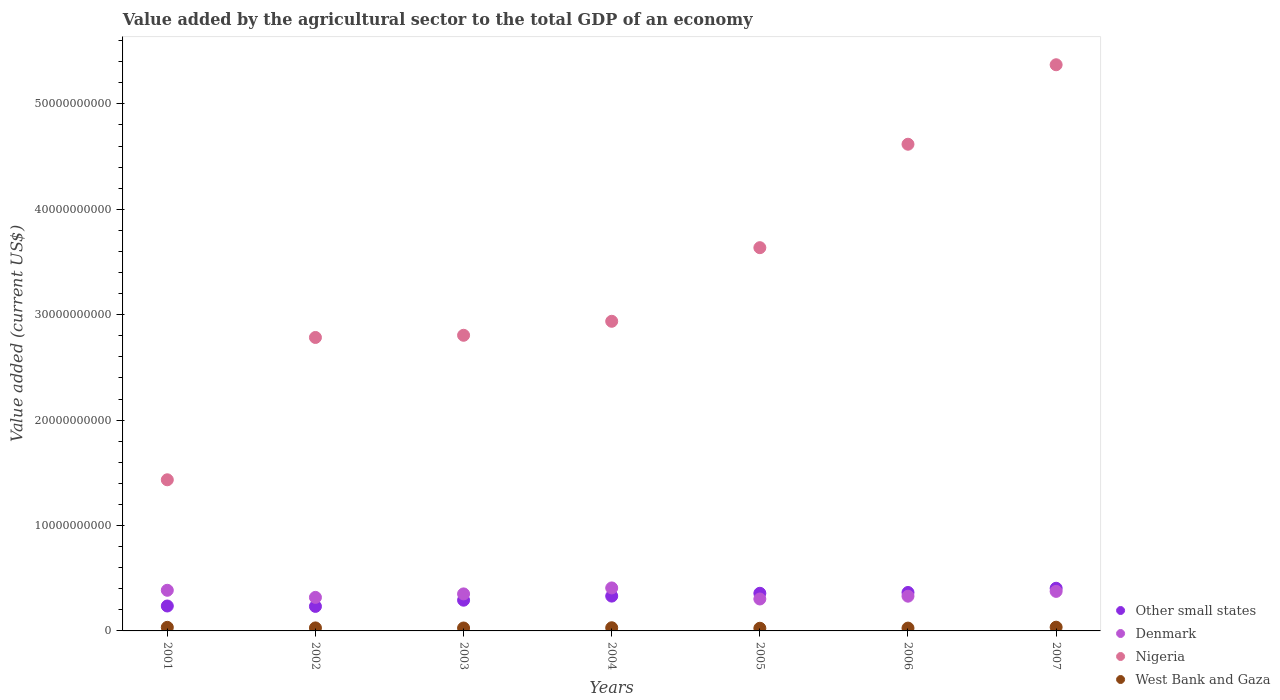How many different coloured dotlines are there?
Provide a short and direct response. 4. What is the value added by the agricultural sector to the total GDP in Nigeria in 2001?
Offer a terse response. 1.43e+1. Across all years, what is the maximum value added by the agricultural sector to the total GDP in West Bank and Gaza?
Give a very brief answer. 3.54e+08. Across all years, what is the minimum value added by the agricultural sector to the total GDP in Other small states?
Ensure brevity in your answer.  2.33e+09. What is the total value added by the agricultural sector to the total GDP in Other small states in the graph?
Keep it short and to the point. 2.22e+1. What is the difference between the value added by the agricultural sector to the total GDP in Nigeria in 2002 and that in 2004?
Provide a succinct answer. -1.53e+09. What is the difference between the value added by the agricultural sector to the total GDP in West Bank and Gaza in 2002 and the value added by the agricultural sector to the total GDP in Denmark in 2001?
Give a very brief answer. -3.57e+09. What is the average value added by the agricultural sector to the total GDP in West Bank and Gaza per year?
Your response must be concise. 2.97e+08. In the year 2002, what is the difference between the value added by the agricultural sector to the total GDP in Denmark and value added by the agricultural sector to the total GDP in Nigeria?
Give a very brief answer. -2.47e+1. What is the ratio of the value added by the agricultural sector to the total GDP in West Bank and Gaza in 2002 to that in 2006?
Offer a very short reply. 1.07. Is the value added by the agricultural sector to the total GDP in Denmark in 2001 less than that in 2002?
Offer a terse response. No. Is the difference between the value added by the agricultural sector to the total GDP in Denmark in 2001 and 2005 greater than the difference between the value added by the agricultural sector to the total GDP in Nigeria in 2001 and 2005?
Keep it short and to the point. Yes. What is the difference between the highest and the second highest value added by the agricultural sector to the total GDP in West Bank and Gaza?
Ensure brevity in your answer.  1.41e+07. What is the difference between the highest and the lowest value added by the agricultural sector to the total GDP in West Bank and Gaza?
Ensure brevity in your answer.  1.00e+08. Is the sum of the value added by the agricultural sector to the total GDP in Denmark in 2004 and 2006 greater than the maximum value added by the agricultural sector to the total GDP in Nigeria across all years?
Make the answer very short. No. Is it the case that in every year, the sum of the value added by the agricultural sector to the total GDP in Denmark and value added by the agricultural sector to the total GDP in Other small states  is greater than the value added by the agricultural sector to the total GDP in Nigeria?
Give a very brief answer. No. Is the value added by the agricultural sector to the total GDP in West Bank and Gaza strictly greater than the value added by the agricultural sector to the total GDP in Denmark over the years?
Make the answer very short. No. How many dotlines are there?
Keep it short and to the point. 4. Does the graph contain any zero values?
Provide a short and direct response. No. Where does the legend appear in the graph?
Provide a succinct answer. Bottom right. How many legend labels are there?
Your answer should be compact. 4. How are the legend labels stacked?
Give a very brief answer. Vertical. What is the title of the graph?
Your answer should be very brief. Value added by the agricultural sector to the total GDP of an economy. Does "El Salvador" appear as one of the legend labels in the graph?
Your answer should be very brief. No. What is the label or title of the X-axis?
Provide a short and direct response. Years. What is the label or title of the Y-axis?
Provide a short and direct response. Value added (current US$). What is the Value added (current US$) of Other small states in 2001?
Keep it short and to the point. 2.36e+09. What is the Value added (current US$) in Denmark in 2001?
Provide a succinct answer. 3.86e+09. What is the Value added (current US$) of Nigeria in 2001?
Offer a terse response. 1.43e+1. What is the Value added (current US$) in West Bank and Gaza in 2001?
Your answer should be compact. 3.40e+08. What is the Value added (current US$) in Other small states in 2002?
Your answer should be compact. 2.33e+09. What is the Value added (current US$) of Denmark in 2002?
Keep it short and to the point. 3.18e+09. What is the Value added (current US$) in Nigeria in 2002?
Provide a short and direct response. 2.78e+1. What is the Value added (current US$) in West Bank and Gaza in 2002?
Make the answer very short. 2.86e+08. What is the Value added (current US$) of Other small states in 2003?
Offer a terse response. 2.92e+09. What is the Value added (current US$) in Denmark in 2003?
Your response must be concise. 3.51e+09. What is the Value added (current US$) in Nigeria in 2003?
Offer a very short reply. 2.80e+1. What is the Value added (current US$) in West Bank and Gaza in 2003?
Provide a succinct answer. 2.76e+08. What is the Value added (current US$) in Other small states in 2004?
Provide a short and direct response. 3.30e+09. What is the Value added (current US$) of Denmark in 2004?
Provide a succinct answer. 4.08e+09. What is the Value added (current US$) in Nigeria in 2004?
Your response must be concise. 2.94e+1. What is the Value added (current US$) of West Bank and Gaza in 2004?
Offer a very short reply. 3.00e+08. What is the Value added (current US$) in Other small states in 2005?
Provide a succinct answer. 3.57e+09. What is the Value added (current US$) of Denmark in 2005?
Your response must be concise. 3.03e+09. What is the Value added (current US$) of Nigeria in 2005?
Keep it short and to the point. 3.64e+1. What is the Value added (current US$) in West Bank and Gaza in 2005?
Make the answer very short. 2.53e+08. What is the Value added (current US$) of Other small states in 2006?
Your answer should be compact. 3.65e+09. What is the Value added (current US$) of Denmark in 2006?
Your answer should be very brief. 3.30e+09. What is the Value added (current US$) in Nigeria in 2006?
Offer a very short reply. 4.62e+1. What is the Value added (current US$) of West Bank and Gaza in 2006?
Keep it short and to the point. 2.68e+08. What is the Value added (current US$) in Other small states in 2007?
Offer a very short reply. 4.05e+09. What is the Value added (current US$) in Denmark in 2007?
Make the answer very short. 3.75e+09. What is the Value added (current US$) in Nigeria in 2007?
Provide a succinct answer. 5.37e+1. What is the Value added (current US$) in West Bank and Gaza in 2007?
Make the answer very short. 3.54e+08. Across all years, what is the maximum Value added (current US$) of Other small states?
Ensure brevity in your answer.  4.05e+09. Across all years, what is the maximum Value added (current US$) in Denmark?
Your answer should be very brief. 4.08e+09. Across all years, what is the maximum Value added (current US$) of Nigeria?
Your response must be concise. 5.37e+1. Across all years, what is the maximum Value added (current US$) of West Bank and Gaza?
Your response must be concise. 3.54e+08. Across all years, what is the minimum Value added (current US$) of Other small states?
Provide a short and direct response. 2.33e+09. Across all years, what is the minimum Value added (current US$) of Denmark?
Provide a succinct answer. 3.03e+09. Across all years, what is the minimum Value added (current US$) in Nigeria?
Provide a short and direct response. 1.43e+1. Across all years, what is the minimum Value added (current US$) of West Bank and Gaza?
Give a very brief answer. 2.53e+08. What is the total Value added (current US$) in Other small states in the graph?
Offer a terse response. 2.22e+1. What is the total Value added (current US$) in Denmark in the graph?
Keep it short and to the point. 2.47e+1. What is the total Value added (current US$) of Nigeria in the graph?
Offer a terse response. 2.36e+11. What is the total Value added (current US$) in West Bank and Gaza in the graph?
Offer a terse response. 2.08e+09. What is the difference between the Value added (current US$) in Other small states in 2001 and that in 2002?
Your answer should be very brief. 3.70e+07. What is the difference between the Value added (current US$) of Denmark in 2001 and that in 2002?
Keep it short and to the point. 6.74e+08. What is the difference between the Value added (current US$) in Nigeria in 2001 and that in 2002?
Make the answer very short. -1.35e+1. What is the difference between the Value added (current US$) in West Bank and Gaza in 2001 and that in 2002?
Your answer should be compact. 5.38e+07. What is the difference between the Value added (current US$) of Other small states in 2001 and that in 2003?
Make the answer very short. -5.50e+08. What is the difference between the Value added (current US$) in Denmark in 2001 and that in 2003?
Offer a very short reply. 3.42e+08. What is the difference between the Value added (current US$) in Nigeria in 2001 and that in 2003?
Your answer should be very brief. -1.37e+1. What is the difference between the Value added (current US$) of West Bank and Gaza in 2001 and that in 2003?
Ensure brevity in your answer.  6.32e+07. What is the difference between the Value added (current US$) in Other small states in 2001 and that in 2004?
Provide a short and direct response. -9.38e+08. What is the difference between the Value added (current US$) in Denmark in 2001 and that in 2004?
Your answer should be very brief. -2.23e+08. What is the difference between the Value added (current US$) in Nigeria in 2001 and that in 2004?
Provide a succinct answer. -1.50e+1. What is the difference between the Value added (current US$) of West Bank and Gaza in 2001 and that in 2004?
Keep it short and to the point. 3.97e+07. What is the difference between the Value added (current US$) in Other small states in 2001 and that in 2005?
Offer a very short reply. -1.21e+09. What is the difference between the Value added (current US$) of Denmark in 2001 and that in 2005?
Make the answer very short. 8.25e+08. What is the difference between the Value added (current US$) of Nigeria in 2001 and that in 2005?
Provide a short and direct response. -2.20e+1. What is the difference between the Value added (current US$) of West Bank and Gaza in 2001 and that in 2005?
Your response must be concise. 8.61e+07. What is the difference between the Value added (current US$) in Other small states in 2001 and that in 2006?
Ensure brevity in your answer.  -1.28e+09. What is the difference between the Value added (current US$) in Denmark in 2001 and that in 2006?
Provide a short and direct response. 5.59e+08. What is the difference between the Value added (current US$) of Nigeria in 2001 and that in 2006?
Your answer should be compact. -3.18e+1. What is the difference between the Value added (current US$) in West Bank and Gaza in 2001 and that in 2006?
Your response must be concise. 7.17e+07. What is the difference between the Value added (current US$) in Other small states in 2001 and that in 2007?
Your response must be concise. -1.68e+09. What is the difference between the Value added (current US$) of Denmark in 2001 and that in 2007?
Make the answer very short. 1.04e+08. What is the difference between the Value added (current US$) in Nigeria in 2001 and that in 2007?
Your answer should be compact. -3.94e+1. What is the difference between the Value added (current US$) of West Bank and Gaza in 2001 and that in 2007?
Ensure brevity in your answer.  -1.41e+07. What is the difference between the Value added (current US$) in Other small states in 2002 and that in 2003?
Offer a very short reply. -5.87e+08. What is the difference between the Value added (current US$) in Denmark in 2002 and that in 2003?
Ensure brevity in your answer.  -3.31e+08. What is the difference between the Value added (current US$) of Nigeria in 2002 and that in 2003?
Your answer should be very brief. -2.08e+08. What is the difference between the Value added (current US$) in West Bank and Gaza in 2002 and that in 2003?
Ensure brevity in your answer.  9.34e+06. What is the difference between the Value added (current US$) of Other small states in 2002 and that in 2004?
Ensure brevity in your answer.  -9.75e+08. What is the difference between the Value added (current US$) in Denmark in 2002 and that in 2004?
Ensure brevity in your answer.  -8.97e+08. What is the difference between the Value added (current US$) of Nigeria in 2002 and that in 2004?
Provide a short and direct response. -1.53e+09. What is the difference between the Value added (current US$) in West Bank and Gaza in 2002 and that in 2004?
Your answer should be compact. -1.41e+07. What is the difference between the Value added (current US$) of Other small states in 2002 and that in 2005?
Offer a terse response. -1.24e+09. What is the difference between the Value added (current US$) of Denmark in 2002 and that in 2005?
Make the answer very short. 1.52e+08. What is the difference between the Value added (current US$) of Nigeria in 2002 and that in 2005?
Your answer should be compact. -8.52e+09. What is the difference between the Value added (current US$) of West Bank and Gaza in 2002 and that in 2005?
Your response must be concise. 3.23e+07. What is the difference between the Value added (current US$) in Other small states in 2002 and that in 2006?
Keep it short and to the point. -1.32e+09. What is the difference between the Value added (current US$) in Denmark in 2002 and that in 2006?
Keep it short and to the point. -1.14e+08. What is the difference between the Value added (current US$) in Nigeria in 2002 and that in 2006?
Ensure brevity in your answer.  -1.83e+1. What is the difference between the Value added (current US$) of West Bank and Gaza in 2002 and that in 2006?
Provide a succinct answer. 1.79e+07. What is the difference between the Value added (current US$) of Other small states in 2002 and that in 2007?
Offer a very short reply. -1.72e+09. What is the difference between the Value added (current US$) of Denmark in 2002 and that in 2007?
Provide a short and direct response. -5.70e+08. What is the difference between the Value added (current US$) in Nigeria in 2002 and that in 2007?
Make the answer very short. -2.59e+1. What is the difference between the Value added (current US$) in West Bank and Gaza in 2002 and that in 2007?
Provide a succinct answer. -6.79e+07. What is the difference between the Value added (current US$) of Other small states in 2003 and that in 2004?
Provide a succinct answer. -3.88e+08. What is the difference between the Value added (current US$) in Denmark in 2003 and that in 2004?
Offer a very short reply. -5.65e+08. What is the difference between the Value added (current US$) of Nigeria in 2003 and that in 2004?
Provide a succinct answer. -1.33e+09. What is the difference between the Value added (current US$) of West Bank and Gaza in 2003 and that in 2004?
Keep it short and to the point. -2.35e+07. What is the difference between the Value added (current US$) in Other small states in 2003 and that in 2005?
Your answer should be compact. -6.55e+08. What is the difference between the Value added (current US$) in Denmark in 2003 and that in 2005?
Provide a short and direct response. 4.83e+08. What is the difference between the Value added (current US$) of Nigeria in 2003 and that in 2005?
Give a very brief answer. -8.31e+09. What is the difference between the Value added (current US$) of West Bank and Gaza in 2003 and that in 2005?
Offer a very short reply. 2.30e+07. What is the difference between the Value added (current US$) of Other small states in 2003 and that in 2006?
Offer a terse response. -7.32e+08. What is the difference between the Value added (current US$) in Denmark in 2003 and that in 2006?
Your answer should be very brief. 2.17e+08. What is the difference between the Value added (current US$) in Nigeria in 2003 and that in 2006?
Make the answer very short. -1.81e+1. What is the difference between the Value added (current US$) of West Bank and Gaza in 2003 and that in 2006?
Make the answer very short. 8.54e+06. What is the difference between the Value added (current US$) in Other small states in 2003 and that in 2007?
Offer a very short reply. -1.13e+09. What is the difference between the Value added (current US$) in Denmark in 2003 and that in 2007?
Your answer should be compact. -2.38e+08. What is the difference between the Value added (current US$) of Nigeria in 2003 and that in 2007?
Make the answer very short. -2.57e+1. What is the difference between the Value added (current US$) of West Bank and Gaza in 2003 and that in 2007?
Give a very brief answer. -7.73e+07. What is the difference between the Value added (current US$) of Other small states in 2004 and that in 2005?
Make the answer very short. -2.68e+08. What is the difference between the Value added (current US$) of Denmark in 2004 and that in 2005?
Provide a short and direct response. 1.05e+09. What is the difference between the Value added (current US$) in Nigeria in 2004 and that in 2005?
Your answer should be very brief. -6.98e+09. What is the difference between the Value added (current US$) in West Bank and Gaza in 2004 and that in 2005?
Offer a terse response. 4.64e+07. What is the difference between the Value added (current US$) of Other small states in 2004 and that in 2006?
Offer a very short reply. -3.44e+08. What is the difference between the Value added (current US$) in Denmark in 2004 and that in 2006?
Your answer should be very brief. 7.82e+08. What is the difference between the Value added (current US$) in Nigeria in 2004 and that in 2006?
Your response must be concise. -1.68e+1. What is the difference between the Value added (current US$) in West Bank and Gaza in 2004 and that in 2006?
Provide a short and direct response. 3.20e+07. What is the difference between the Value added (current US$) in Other small states in 2004 and that in 2007?
Your answer should be very brief. -7.44e+08. What is the difference between the Value added (current US$) in Denmark in 2004 and that in 2007?
Offer a terse response. 3.27e+08. What is the difference between the Value added (current US$) in Nigeria in 2004 and that in 2007?
Keep it short and to the point. -2.43e+1. What is the difference between the Value added (current US$) of West Bank and Gaza in 2004 and that in 2007?
Provide a succinct answer. -5.38e+07. What is the difference between the Value added (current US$) in Other small states in 2005 and that in 2006?
Your response must be concise. -7.65e+07. What is the difference between the Value added (current US$) in Denmark in 2005 and that in 2006?
Your response must be concise. -2.66e+08. What is the difference between the Value added (current US$) in Nigeria in 2005 and that in 2006?
Your answer should be compact. -9.81e+09. What is the difference between the Value added (current US$) of West Bank and Gaza in 2005 and that in 2006?
Keep it short and to the point. -1.44e+07. What is the difference between the Value added (current US$) of Other small states in 2005 and that in 2007?
Make the answer very short. -4.77e+08. What is the difference between the Value added (current US$) in Denmark in 2005 and that in 2007?
Give a very brief answer. -7.21e+08. What is the difference between the Value added (current US$) of Nigeria in 2005 and that in 2007?
Offer a terse response. -1.74e+1. What is the difference between the Value added (current US$) in West Bank and Gaza in 2005 and that in 2007?
Keep it short and to the point. -1.00e+08. What is the difference between the Value added (current US$) of Other small states in 2006 and that in 2007?
Give a very brief answer. -4.00e+08. What is the difference between the Value added (current US$) in Denmark in 2006 and that in 2007?
Provide a short and direct response. -4.55e+08. What is the difference between the Value added (current US$) in Nigeria in 2006 and that in 2007?
Your response must be concise. -7.54e+09. What is the difference between the Value added (current US$) in West Bank and Gaza in 2006 and that in 2007?
Offer a very short reply. -8.58e+07. What is the difference between the Value added (current US$) in Other small states in 2001 and the Value added (current US$) in Denmark in 2002?
Your answer should be very brief. -8.17e+08. What is the difference between the Value added (current US$) of Other small states in 2001 and the Value added (current US$) of Nigeria in 2002?
Your answer should be very brief. -2.55e+1. What is the difference between the Value added (current US$) in Other small states in 2001 and the Value added (current US$) in West Bank and Gaza in 2002?
Your response must be concise. 2.08e+09. What is the difference between the Value added (current US$) in Denmark in 2001 and the Value added (current US$) in Nigeria in 2002?
Provide a succinct answer. -2.40e+1. What is the difference between the Value added (current US$) in Denmark in 2001 and the Value added (current US$) in West Bank and Gaza in 2002?
Give a very brief answer. 3.57e+09. What is the difference between the Value added (current US$) in Nigeria in 2001 and the Value added (current US$) in West Bank and Gaza in 2002?
Your answer should be very brief. 1.41e+1. What is the difference between the Value added (current US$) of Other small states in 2001 and the Value added (current US$) of Denmark in 2003?
Make the answer very short. -1.15e+09. What is the difference between the Value added (current US$) of Other small states in 2001 and the Value added (current US$) of Nigeria in 2003?
Make the answer very short. -2.57e+1. What is the difference between the Value added (current US$) in Other small states in 2001 and the Value added (current US$) in West Bank and Gaza in 2003?
Your answer should be compact. 2.09e+09. What is the difference between the Value added (current US$) of Denmark in 2001 and the Value added (current US$) of Nigeria in 2003?
Your answer should be very brief. -2.42e+1. What is the difference between the Value added (current US$) in Denmark in 2001 and the Value added (current US$) in West Bank and Gaza in 2003?
Make the answer very short. 3.58e+09. What is the difference between the Value added (current US$) of Nigeria in 2001 and the Value added (current US$) of West Bank and Gaza in 2003?
Your response must be concise. 1.41e+1. What is the difference between the Value added (current US$) of Other small states in 2001 and the Value added (current US$) of Denmark in 2004?
Keep it short and to the point. -1.71e+09. What is the difference between the Value added (current US$) in Other small states in 2001 and the Value added (current US$) in Nigeria in 2004?
Offer a terse response. -2.70e+1. What is the difference between the Value added (current US$) of Other small states in 2001 and the Value added (current US$) of West Bank and Gaza in 2004?
Your response must be concise. 2.06e+09. What is the difference between the Value added (current US$) in Denmark in 2001 and the Value added (current US$) in Nigeria in 2004?
Make the answer very short. -2.55e+1. What is the difference between the Value added (current US$) of Denmark in 2001 and the Value added (current US$) of West Bank and Gaza in 2004?
Provide a succinct answer. 3.56e+09. What is the difference between the Value added (current US$) of Nigeria in 2001 and the Value added (current US$) of West Bank and Gaza in 2004?
Offer a very short reply. 1.40e+1. What is the difference between the Value added (current US$) in Other small states in 2001 and the Value added (current US$) in Denmark in 2005?
Offer a very short reply. -6.65e+08. What is the difference between the Value added (current US$) of Other small states in 2001 and the Value added (current US$) of Nigeria in 2005?
Offer a very short reply. -3.40e+1. What is the difference between the Value added (current US$) in Other small states in 2001 and the Value added (current US$) in West Bank and Gaza in 2005?
Your answer should be compact. 2.11e+09. What is the difference between the Value added (current US$) of Denmark in 2001 and the Value added (current US$) of Nigeria in 2005?
Offer a very short reply. -3.25e+1. What is the difference between the Value added (current US$) of Denmark in 2001 and the Value added (current US$) of West Bank and Gaza in 2005?
Your answer should be compact. 3.60e+09. What is the difference between the Value added (current US$) of Nigeria in 2001 and the Value added (current US$) of West Bank and Gaza in 2005?
Provide a succinct answer. 1.41e+1. What is the difference between the Value added (current US$) of Other small states in 2001 and the Value added (current US$) of Denmark in 2006?
Your response must be concise. -9.31e+08. What is the difference between the Value added (current US$) of Other small states in 2001 and the Value added (current US$) of Nigeria in 2006?
Ensure brevity in your answer.  -4.38e+1. What is the difference between the Value added (current US$) of Other small states in 2001 and the Value added (current US$) of West Bank and Gaza in 2006?
Make the answer very short. 2.10e+09. What is the difference between the Value added (current US$) of Denmark in 2001 and the Value added (current US$) of Nigeria in 2006?
Your answer should be compact. -4.23e+1. What is the difference between the Value added (current US$) of Denmark in 2001 and the Value added (current US$) of West Bank and Gaza in 2006?
Provide a succinct answer. 3.59e+09. What is the difference between the Value added (current US$) in Nigeria in 2001 and the Value added (current US$) in West Bank and Gaza in 2006?
Make the answer very short. 1.41e+1. What is the difference between the Value added (current US$) in Other small states in 2001 and the Value added (current US$) in Denmark in 2007?
Offer a terse response. -1.39e+09. What is the difference between the Value added (current US$) of Other small states in 2001 and the Value added (current US$) of Nigeria in 2007?
Make the answer very short. -5.14e+1. What is the difference between the Value added (current US$) of Other small states in 2001 and the Value added (current US$) of West Bank and Gaza in 2007?
Your response must be concise. 2.01e+09. What is the difference between the Value added (current US$) of Denmark in 2001 and the Value added (current US$) of Nigeria in 2007?
Provide a short and direct response. -4.99e+1. What is the difference between the Value added (current US$) of Denmark in 2001 and the Value added (current US$) of West Bank and Gaza in 2007?
Keep it short and to the point. 3.50e+09. What is the difference between the Value added (current US$) of Nigeria in 2001 and the Value added (current US$) of West Bank and Gaza in 2007?
Your answer should be very brief. 1.40e+1. What is the difference between the Value added (current US$) of Other small states in 2002 and the Value added (current US$) of Denmark in 2003?
Keep it short and to the point. -1.19e+09. What is the difference between the Value added (current US$) of Other small states in 2002 and the Value added (current US$) of Nigeria in 2003?
Make the answer very short. -2.57e+1. What is the difference between the Value added (current US$) of Other small states in 2002 and the Value added (current US$) of West Bank and Gaza in 2003?
Keep it short and to the point. 2.05e+09. What is the difference between the Value added (current US$) in Denmark in 2002 and the Value added (current US$) in Nigeria in 2003?
Offer a very short reply. -2.49e+1. What is the difference between the Value added (current US$) of Denmark in 2002 and the Value added (current US$) of West Bank and Gaza in 2003?
Provide a short and direct response. 2.91e+09. What is the difference between the Value added (current US$) in Nigeria in 2002 and the Value added (current US$) in West Bank and Gaza in 2003?
Offer a very short reply. 2.76e+1. What is the difference between the Value added (current US$) of Other small states in 2002 and the Value added (current US$) of Denmark in 2004?
Make the answer very short. -1.75e+09. What is the difference between the Value added (current US$) in Other small states in 2002 and the Value added (current US$) in Nigeria in 2004?
Offer a very short reply. -2.70e+1. What is the difference between the Value added (current US$) in Other small states in 2002 and the Value added (current US$) in West Bank and Gaza in 2004?
Provide a short and direct response. 2.03e+09. What is the difference between the Value added (current US$) of Denmark in 2002 and the Value added (current US$) of Nigeria in 2004?
Ensure brevity in your answer.  -2.62e+1. What is the difference between the Value added (current US$) of Denmark in 2002 and the Value added (current US$) of West Bank and Gaza in 2004?
Ensure brevity in your answer.  2.88e+09. What is the difference between the Value added (current US$) in Nigeria in 2002 and the Value added (current US$) in West Bank and Gaza in 2004?
Ensure brevity in your answer.  2.75e+1. What is the difference between the Value added (current US$) of Other small states in 2002 and the Value added (current US$) of Denmark in 2005?
Make the answer very short. -7.02e+08. What is the difference between the Value added (current US$) in Other small states in 2002 and the Value added (current US$) in Nigeria in 2005?
Give a very brief answer. -3.40e+1. What is the difference between the Value added (current US$) of Other small states in 2002 and the Value added (current US$) of West Bank and Gaza in 2005?
Your response must be concise. 2.07e+09. What is the difference between the Value added (current US$) of Denmark in 2002 and the Value added (current US$) of Nigeria in 2005?
Offer a very short reply. -3.32e+1. What is the difference between the Value added (current US$) in Denmark in 2002 and the Value added (current US$) in West Bank and Gaza in 2005?
Offer a terse response. 2.93e+09. What is the difference between the Value added (current US$) in Nigeria in 2002 and the Value added (current US$) in West Bank and Gaza in 2005?
Make the answer very short. 2.76e+1. What is the difference between the Value added (current US$) of Other small states in 2002 and the Value added (current US$) of Denmark in 2006?
Keep it short and to the point. -9.68e+08. What is the difference between the Value added (current US$) in Other small states in 2002 and the Value added (current US$) in Nigeria in 2006?
Your response must be concise. -4.38e+1. What is the difference between the Value added (current US$) of Other small states in 2002 and the Value added (current US$) of West Bank and Gaza in 2006?
Give a very brief answer. 2.06e+09. What is the difference between the Value added (current US$) of Denmark in 2002 and the Value added (current US$) of Nigeria in 2006?
Offer a terse response. -4.30e+1. What is the difference between the Value added (current US$) in Denmark in 2002 and the Value added (current US$) in West Bank and Gaza in 2006?
Your answer should be very brief. 2.91e+09. What is the difference between the Value added (current US$) in Nigeria in 2002 and the Value added (current US$) in West Bank and Gaza in 2006?
Offer a very short reply. 2.76e+1. What is the difference between the Value added (current US$) of Other small states in 2002 and the Value added (current US$) of Denmark in 2007?
Provide a short and direct response. -1.42e+09. What is the difference between the Value added (current US$) of Other small states in 2002 and the Value added (current US$) of Nigeria in 2007?
Your answer should be compact. -5.14e+1. What is the difference between the Value added (current US$) of Other small states in 2002 and the Value added (current US$) of West Bank and Gaza in 2007?
Give a very brief answer. 1.97e+09. What is the difference between the Value added (current US$) in Denmark in 2002 and the Value added (current US$) in Nigeria in 2007?
Keep it short and to the point. -5.05e+1. What is the difference between the Value added (current US$) of Denmark in 2002 and the Value added (current US$) of West Bank and Gaza in 2007?
Provide a short and direct response. 2.83e+09. What is the difference between the Value added (current US$) in Nigeria in 2002 and the Value added (current US$) in West Bank and Gaza in 2007?
Give a very brief answer. 2.75e+1. What is the difference between the Value added (current US$) in Other small states in 2003 and the Value added (current US$) in Denmark in 2004?
Ensure brevity in your answer.  -1.16e+09. What is the difference between the Value added (current US$) of Other small states in 2003 and the Value added (current US$) of Nigeria in 2004?
Provide a short and direct response. -2.65e+1. What is the difference between the Value added (current US$) in Other small states in 2003 and the Value added (current US$) in West Bank and Gaza in 2004?
Keep it short and to the point. 2.62e+09. What is the difference between the Value added (current US$) of Denmark in 2003 and the Value added (current US$) of Nigeria in 2004?
Offer a terse response. -2.59e+1. What is the difference between the Value added (current US$) in Denmark in 2003 and the Value added (current US$) in West Bank and Gaza in 2004?
Ensure brevity in your answer.  3.21e+09. What is the difference between the Value added (current US$) in Nigeria in 2003 and the Value added (current US$) in West Bank and Gaza in 2004?
Offer a terse response. 2.77e+1. What is the difference between the Value added (current US$) in Other small states in 2003 and the Value added (current US$) in Denmark in 2005?
Provide a short and direct response. -1.15e+08. What is the difference between the Value added (current US$) in Other small states in 2003 and the Value added (current US$) in Nigeria in 2005?
Offer a terse response. -3.34e+1. What is the difference between the Value added (current US$) in Other small states in 2003 and the Value added (current US$) in West Bank and Gaza in 2005?
Provide a succinct answer. 2.66e+09. What is the difference between the Value added (current US$) in Denmark in 2003 and the Value added (current US$) in Nigeria in 2005?
Provide a short and direct response. -3.28e+1. What is the difference between the Value added (current US$) of Denmark in 2003 and the Value added (current US$) of West Bank and Gaza in 2005?
Offer a very short reply. 3.26e+09. What is the difference between the Value added (current US$) of Nigeria in 2003 and the Value added (current US$) of West Bank and Gaza in 2005?
Your answer should be very brief. 2.78e+1. What is the difference between the Value added (current US$) of Other small states in 2003 and the Value added (current US$) of Denmark in 2006?
Provide a short and direct response. -3.81e+08. What is the difference between the Value added (current US$) of Other small states in 2003 and the Value added (current US$) of Nigeria in 2006?
Your answer should be very brief. -4.33e+1. What is the difference between the Value added (current US$) of Other small states in 2003 and the Value added (current US$) of West Bank and Gaza in 2006?
Give a very brief answer. 2.65e+09. What is the difference between the Value added (current US$) in Denmark in 2003 and the Value added (current US$) in Nigeria in 2006?
Provide a short and direct response. -4.27e+1. What is the difference between the Value added (current US$) of Denmark in 2003 and the Value added (current US$) of West Bank and Gaza in 2006?
Offer a terse response. 3.25e+09. What is the difference between the Value added (current US$) in Nigeria in 2003 and the Value added (current US$) in West Bank and Gaza in 2006?
Your response must be concise. 2.78e+1. What is the difference between the Value added (current US$) in Other small states in 2003 and the Value added (current US$) in Denmark in 2007?
Ensure brevity in your answer.  -8.36e+08. What is the difference between the Value added (current US$) of Other small states in 2003 and the Value added (current US$) of Nigeria in 2007?
Make the answer very short. -5.08e+1. What is the difference between the Value added (current US$) of Other small states in 2003 and the Value added (current US$) of West Bank and Gaza in 2007?
Offer a terse response. 2.56e+09. What is the difference between the Value added (current US$) of Denmark in 2003 and the Value added (current US$) of Nigeria in 2007?
Offer a very short reply. -5.02e+1. What is the difference between the Value added (current US$) in Denmark in 2003 and the Value added (current US$) in West Bank and Gaza in 2007?
Make the answer very short. 3.16e+09. What is the difference between the Value added (current US$) of Nigeria in 2003 and the Value added (current US$) of West Bank and Gaza in 2007?
Provide a succinct answer. 2.77e+1. What is the difference between the Value added (current US$) of Other small states in 2004 and the Value added (current US$) of Denmark in 2005?
Provide a short and direct response. 2.73e+08. What is the difference between the Value added (current US$) of Other small states in 2004 and the Value added (current US$) of Nigeria in 2005?
Provide a short and direct response. -3.31e+1. What is the difference between the Value added (current US$) in Other small states in 2004 and the Value added (current US$) in West Bank and Gaza in 2005?
Your answer should be very brief. 3.05e+09. What is the difference between the Value added (current US$) of Denmark in 2004 and the Value added (current US$) of Nigeria in 2005?
Keep it short and to the point. -3.23e+1. What is the difference between the Value added (current US$) of Denmark in 2004 and the Value added (current US$) of West Bank and Gaza in 2005?
Provide a succinct answer. 3.83e+09. What is the difference between the Value added (current US$) of Nigeria in 2004 and the Value added (current US$) of West Bank and Gaza in 2005?
Your answer should be compact. 2.91e+1. What is the difference between the Value added (current US$) of Other small states in 2004 and the Value added (current US$) of Denmark in 2006?
Provide a short and direct response. 6.60e+06. What is the difference between the Value added (current US$) in Other small states in 2004 and the Value added (current US$) in Nigeria in 2006?
Offer a very short reply. -4.29e+1. What is the difference between the Value added (current US$) of Other small states in 2004 and the Value added (current US$) of West Bank and Gaza in 2006?
Provide a succinct answer. 3.03e+09. What is the difference between the Value added (current US$) in Denmark in 2004 and the Value added (current US$) in Nigeria in 2006?
Keep it short and to the point. -4.21e+1. What is the difference between the Value added (current US$) in Denmark in 2004 and the Value added (current US$) in West Bank and Gaza in 2006?
Provide a succinct answer. 3.81e+09. What is the difference between the Value added (current US$) of Nigeria in 2004 and the Value added (current US$) of West Bank and Gaza in 2006?
Offer a very short reply. 2.91e+1. What is the difference between the Value added (current US$) of Other small states in 2004 and the Value added (current US$) of Denmark in 2007?
Ensure brevity in your answer.  -4.48e+08. What is the difference between the Value added (current US$) in Other small states in 2004 and the Value added (current US$) in Nigeria in 2007?
Ensure brevity in your answer.  -5.04e+1. What is the difference between the Value added (current US$) in Other small states in 2004 and the Value added (current US$) in West Bank and Gaza in 2007?
Give a very brief answer. 2.95e+09. What is the difference between the Value added (current US$) of Denmark in 2004 and the Value added (current US$) of Nigeria in 2007?
Give a very brief answer. -4.96e+1. What is the difference between the Value added (current US$) of Denmark in 2004 and the Value added (current US$) of West Bank and Gaza in 2007?
Provide a short and direct response. 3.72e+09. What is the difference between the Value added (current US$) of Nigeria in 2004 and the Value added (current US$) of West Bank and Gaza in 2007?
Provide a succinct answer. 2.90e+1. What is the difference between the Value added (current US$) in Other small states in 2005 and the Value added (current US$) in Denmark in 2006?
Your answer should be compact. 2.74e+08. What is the difference between the Value added (current US$) of Other small states in 2005 and the Value added (current US$) of Nigeria in 2006?
Provide a succinct answer. -4.26e+1. What is the difference between the Value added (current US$) of Other small states in 2005 and the Value added (current US$) of West Bank and Gaza in 2006?
Offer a very short reply. 3.30e+09. What is the difference between the Value added (current US$) of Denmark in 2005 and the Value added (current US$) of Nigeria in 2006?
Your answer should be very brief. -4.31e+1. What is the difference between the Value added (current US$) of Denmark in 2005 and the Value added (current US$) of West Bank and Gaza in 2006?
Your answer should be very brief. 2.76e+09. What is the difference between the Value added (current US$) of Nigeria in 2005 and the Value added (current US$) of West Bank and Gaza in 2006?
Your answer should be compact. 3.61e+1. What is the difference between the Value added (current US$) in Other small states in 2005 and the Value added (current US$) in Denmark in 2007?
Keep it short and to the point. -1.81e+08. What is the difference between the Value added (current US$) of Other small states in 2005 and the Value added (current US$) of Nigeria in 2007?
Ensure brevity in your answer.  -5.01e+1. What is the difference between the Value added (current US$) in Other small states in 2005 and the Value added (current US$) in West Bank and Gaza in 2007?
Ensure brevity in your answer.  3.22e+09. What is the difference between the Value added (current US$) of Denmark in 2005 and the Value added (current US$) of Nigeria in 2007?
Offer a terse response. -5.07e+1. What is the difference between the Value added (current US$) of Denmark in 2005 and the Value added (current US$) of West Bank and Gaza in 2007?
Your answer should be compact. 2.68e+09. What is the difference between the Value added (current US$) in Nigeria in 2005 and the Value added (current US$) in West Bank and Gaza in 2007?
Your response must be concise. 3.60e+1. What is the difference between the Value added (current US$) of Other small states in 2006 and the Value added (current US$) of Denmark in 2007?
Give a very brief answer. -1.04e+08. What is the difference between the Value added (current US$) of Other small states in 2006 and the Value added (current US$) of Nigeria in 2007?
Offer a very short reply. -5.01e+1. What is the difference between the Value added (current US$) in Other small states in 2006 and the Value added (current US$) in West Bank and Gaza in 2007?
Your answer should be compact. 3.29e+09. What is the difference between the Value added (current US$) in Denmark in 2006 and the Value added (current US$) in Nigeria in 2007?
Offer a very short reply. -5.04e+1. What is the difference between the Value added (current US$) in Denmark in 2006 and the Value added (current US$) in West Bank and Gaza in 2007?
Your answer should be compact. 2.94e+09. What is the difference between the Value added (current US$) in Nigeria in 2006 and the Value added (current US$) in West Bank and Gaza in 2007?
Your response must be concise. 4.58e+1. What is the average Value added (current US$) in Other small states per year?
Make the answer very short. 3.17e+09. What is the average Value added (current US$) of Denmark per year?
Provide a short and direct response. 3.53e+09. What is the average Value added (current US$) in Nigeria per year?
Offer a very short reply. 3.37e+1. What is the average Value added (current US$) of West Bank and Gaza per year?
Offer a very short reply. 2.97e+08. In the year 2001, what is the difference between the Value added (current US$) of Other small states and Value added (current US$) of Denmark?
Keep it short and to the point. -1.49e+09. In the year 2001, what is the difference between the Value added (current US$) in Other small states and Value added (current US$) in Nigeria?
Make the answer very short. -1.20e+1. In the year 2001, what is the difference between the Value added (current US$) in Other small states and Value added (current US$) in West Bank and Gaza?
Give a very brief answer. 2.03e+09. In the year 2001, what is the difference between the Value added (current US$) of Denmark and Value added (current US$) of Nigeria?
Provide a succinct answer. -1.05e+1. In the year 2001, what is the difference between the Value added (current US$) of Denmark and Value added (current US$) of West Bank and Gaza?
Provide a short and direct response. 3.52e+09. In the year 2001, what is the difference between the Value added (current US$) of Nigeria and Value added (current US$) of West Bank and Gaza?
Provide a short and direct response. 1.40e+1. In the year 2002, what is the difference between the Value added (current US$) in Other small states and Value added (current US$) in Denmark?
Your response must be concise. -8.54e+08. In the year 2002, what is the difference between the Value added (current US$) in Other small states and Value added (current US$) in Nigeria?
Make the answer very short. -2.55e+1. In the year 2002, what is the difference between the Value added (current US$) of Other small states and Value added (current US$) of West Bank and Gaza?
Provide a short and direct response. 2.04e+09. In the year 2002, what is the difference between the Value added (current US$) in Denmark and Value added (current US$) in Nigeria?
Offer a terse response. -2.47e+1. In the year 2002, what is the difference between the Value added (current US$) of Denmark and Value added (current US$) of West Bank and Gaza?
Make the answer very short. 2.90e+09. In the year 2002, what is the difference between the Value added (current US$) of Nigeria and Value added (current US$) of West Bank and Gaza?
Ensure brevity in your answer.  2.76e+1. In the year 2003, what is the difference between the Value added (current US$) in Other small states and Value added (current US$) in Denmark?
Your response must be concise. -5.98e+08. In the year 2003, what is the difference between the Value added (current US$) of Other small states and Value added (current US$) of Nigeria?
Provide a succinct answer. -2.51e+1. In the year 2003, what is the difference between the Value added (current US$) in Other small states and Value added (current US$) in West Bank and Gaza?
Give a very brief answer. 2.64e+09. In the year 2003, what is the difference between the Value added (current US$) of Denmark and Value added (current US$) of Nigeria?
Ensure brevity in your answer.  -2.45e+1. In the year 2003, what is the difference between the Value added (current US$) of Denmark and Value added (current US$) of West Bank and Gaza?
Make the answer very short. 3.24e+09. In the year 2003, what is the difference between the Value added (current US$) of Nigeria and Value added (current US$) of West Bank and Gaza?
Provide a succinct answer. 2.78e+1. In the year 2004, what is the difference between the Value added (current US$) of Other small states and Value added (current US$) of Denmark?
Provide a succinct answer. -7.76e+08. In the year 2004, what is the difference between the Value added (current US$) of Other small states and Value added (current US$) of Nigeria?
Provide a short and direct response. -2.61e+1. In the year 2004, what is the difference between the Value added (current US$) of Other small states and Value added (current US$) of West Bank and Gaza?
Offer a very short reply. 3.00e+09. In the year 2004, what is the difference between the Value added (current US$) in Denmark and Value added (current US$) in Nigeria?
Provide a short and direct response. -2.53e+1. In the year 2004, what is the difference between the Value added (current US$) of Denmark and Value added (current US$) of West Bank and Gaza?
Offer a terse response. 3.78e+09. In the year 2004, what is the difference between the Value added (current US$) in Nigeria and Value added (current US$) in West Bank and Gaza?
Offer a very short reply. 2.91e+1. In the year 2005, what is the difference between the Value added (current US$) of Other small states and Value added (current US$) of Denmark?
Keep it short and to the point. 5.41e+08. In the year 2005, what is the difference between the Value added (current US$) of Other small states and Value added (current US$) of Nigeria?
Offer a terse response. -3.28e+1. In the year 2005, what is the difference between the Value added (current US$) of Other small states and Value added (current US$) of West Bank and Gaza?
Ensure brevity in your answer.  3.32e+09. In the year 2005, what is the difference between the Value added (current US$) in Denmark and Value added (current US$) in Nigeria?
Offer a very short reply. -3.33e+1. In the year 2005, what is the difference between the Value added (current US$) in Denmark and Value added (current US$) in West Bank and Gaza?
Provide a short and direct response. 2.78e+09. In the year 2005, what is the difference between the Value added (current US$) in Nigeria and Value added (current US$) in West Bank and Gaza?
Make the answer very short. 3.61e+1. In the year 2006, what is the difference between the Value added (current US$) of Other small states and Value added (current US$) of Denmark?
Make the answer very short. 3.51e+08. In the year 2006, what is the difference between the Value added (current US$) of Other small states and Value added (current US$) of Nigeria?
Keep it short and to the point. -4.25e+1. In the year 2006, what is the difference between the Value added (current US$) in Other small states and Value added (current US$) in West Bank and Gaza?
Your answer should be very brief. 3.38e+09. In the year 2006, what is the difference between the Value added (current US$) of Denmark and Value added (current US$) of Nigeria?
Offer a very short reply. -4.29e+1. In the year 2006, what is the difference between the Value added (current US$) in Denmark and Value added (current US$) in West Bank and Gaza?
Make the answer very short. 3.03e+09. In the year 2006, what is the difference between the Value added (current US$) of Nigeria and Value added (current US$) of West Bank and Gaza?
Provide a succinct answer. 4.59e+1. In the year 2007, what is the difference between the Value added (current US$) in Other small states and Value added (current US$) in Denmark?
Make the answer very short. 2.96e+08. In the year 2007, what is the difference between the Value added (current US$) in Other small states and Value added (current US$) in Nigeria?
Give a very brief answer. -4.97e+1. In the year 2007, what is the difference between the Value added (current US$) of Other small states and Value added (current US$) of West Bank and Gaza?
Provide a succinct answer. 3.69e+09. In the year 2007, what is the difference between the Value added (current US$) of Denmark and Value added (current US$) of Nigeria?
Your answer should be very brief. -5.00e+1. In the year 2007, what is the difference between the Value added (current US$) in Denmark and Value added (current US$) in West Bank and Gaza?
Make the answer very short. 3.40e+09. In the year 2007, what is the difference between the Value added (current US$) of Nigeria and Value added (current US$) of West Bank and Gaza?
Your answer should be compact. 5.34e+1. What is the ratio of the Value added (current US$) in Other small states in 2001 to that in 2002?
Offer a very short reply. 1.02. What is the ratio of the Value added (current US$) in Denmark in 2001 to that in 2002?
Give a very brief answer. 1.21. What is the ratio of the Value added (current US$) in Nigeria in 2001 to that in 2002?
Your response must be concise. 0.52. What is the ratio of the Value added (current US$) of West Bank and Gaza in 2001 to that in 2002?
Your answer should be very brief. 1.19. What is the ratio of the Value added (current US$) in Other small states in 2001 to that in 2003?
Offer a terse response. 0.81. What is the ratio of the Value added (current US$) of Denmark in 2001 to that in 2003?
Ensure brevity in your answer.  1.1. What is the ratio of the Value added (current US$) in Nigeria in 2001 to that in 2003?
Your answer should be very brief. 0.51. What is the ratio of the Value added (current US$) in West Bank and Gaza in 2001 to that in 2003?
Keep it short and to the point. 1.23. What is the ratio of the Value added (current US$) of Other small states in 2001 to that in 2004?
Make the answer very short. 0.72. What is the ratio of the Value added (current US$) of Denmark in 2001 to that in 2004?
Your answer should be compact. 0.95. What is the ratio of the Value added (current US$) of Nigeria in 2001 to that in 2004?
Give a very brief answer. 0.49. What is the ratio of the Value added (current US$) in West Bank and Gaza in 2001 to that in 2004?
Keep it short and to the point. 1.13. What is the ratio of the Value added (current US$) in Other small states in 2001 to that in 2005?
Provide a short and direct response. 0.66. What is the ratio of the Value added (current US$) of Denmark in 2001 to that in 2005?
Your answer should be very brief. 1.27. What is the ratio of the Value added (current US$) of Nigeria in 2001 to that in 2005?
Your answer should be very brief. 0.39. What is the ratio of the Value added (current US$) of West Bank and Gaza in 2001 to that in 2005?
Your response must be concise. 1.34. What is the ratio of the Value added (current US$) in Other small states in 2001 to that in 2006?
Offer a terse response. 0.65. What is the ratio of the Value added (current US$) of Denmark in 2001 to that in 2006?
Give a very brief answer. 1.17. What is the ratio of the Value added (current US$) of Nigeria in 2001 to that in 2006?
Give a very brief answer. 0.31. What is the ratio of the Value added (current US$) of West Bank and Gaza in 2001 to that in 2006?
Give a very brief answer. 1.27. What is the ratio of the Value added (current US$) in Other small states in 2001 to that in 2007?
Provide a short and direct response. 0.58. What is the ratio of the Value added (current US$) in Denmark in 2001 to that in 2007?
Your answer should be very brief. 1.03. What is the ratio of the Value added (current US$) of Nigeria in 2001 to that in 2007?
Provide a succinct answer. 0.27. What is the ratio of the Value added (current US$) in West Bank and Gaza in 2001 to that in 2007?
Keep it short and to the point. 0.96. What is the ratio of the Value added (current US$) of Other small states in 2002 to that in 2003?
Offer a very short reply. 0.8. What is the ratio of the Value added (current US$) in Denmark in 2002 to that in 2003?
Offer a terse response. 0.91. What is the ratio of the Value added (current US$) of West Bank and Gaza in 2002 to that in 2003?
Offer a terse response. 1.03. What is the ratio of the Value added (current US$) of Other small states in 2002 to that in 2004?
Give a very brief answer. 0.7. What is the ratio of the Value added (current US$) of Denmark in 2002 to that in 2004?
Keep it short and to the point. 0.78. What is the ratio of the Value added (current US$) of Nigeria in 2002 to that in 2004?
Give a very brief answer. 0.95. What is the ratio of the Value added (current US$) in West Bank and Gaza in 2002 to that in 2004?
Offer a very short reply. 0.95. What is the ratio of the Value added (current US$) of Other small states in 2002 to that in 2005?
Give a very brief answer. 0.65. What is the ratio of the Value added (current US$) of Denmark in 2002 to that in 2005?
Your response must be concise. 1.05. What is the ratio of the Value added (current US$) in Nigeria in 2002 to that in 2005?
Provide a short and direct response. 0.77. What is the ratio of the Value added (current US$) in West Bank and Gaza in 2002 to that in 2005?
Offer a very short reply. 1.13. What is the ratio of the Value added (current US$) in Other small states in 2002 to that in 2006?
Ensure brevity in your answer.  0.64. What is the ratio of the Value added (current US$) of Denmark in 2002 to that in 2006?
Provide a succinct answer. 0.97. What is the ratio of the Value added (current US$) of Nigeria in 2002 to that in 2006?
Keep it short and to the point. 0.6. What is the ratio of the Value added (current US$) of West Bank and Gaza in 2002 to that in 2006?
Provide a short and direct response. 1.07. What is the ratio of the Value added (current US$) of Other small states in 2002 to that in 2007?
Your response must be concise. 0.58. What is the ratio of the Value added (current US$) in Denmark in 2002 to that in 2007?
Make the answer very short. 0.85. What is the ratio of the Value added (current US$) of Nigeria in 2002 to that in 2007?
Make the answer very short. 0.52. What is the ratio of the Value added (current US$) of West Bank and Gaza in 2002 to that in 2007?
Keep it short and to the point. 0.81. What is the ratio of the Value added (current US$) of Other small states in 2003 to that in 2004?
Offer a terse response. 0.88. What is the ratio of the Value added (current US$) in Denmark in 2003 to that in 2004?
Offer a terse response. 0.86. What is the ratio of the Value added (current US$) of Nigeria in 2003 to that in 2004?
Your answer should be very brief. 0.95. What is the ratio of the Value added (current US$) of West Bank and Gaza in 2003 to that in 2004?
Your answer should be very brief. 0.92. What is the ratio of the Value added (current US$) in Other small states in 2003 to that in 2005?
Your answer should be very brief. 0.82. What is the ratio of the Value added (current US$) in Denmark in 2003 to that in 2005?
Make the answer very short. 1.16. What is the ratio of the Value added (current US$) in Nigeria in 2003 to that in 2005?
Offer a terse response. 0.77. What is the ratio of the Value added (current US$) in West Bank and Gaza in 2003 to that in 2005?
Your answer should be compact. 1.09. What is the ratio of the Value added (current US$) of Other small states in 2003 to that in 2006?
Your answer should be compact. 0.8. What is the ratio of the Value added (current US$) of Denmark in 2003 to that in 2006?
Your response must be concise. 1.07. What is the ratio of the Value added (current US$) in Nigeria in 2003 to that in 2006?
Offer a very short reply. 0.61. What is the ratio of the Value added (current US$) of West Bank and Gaza in 2003 to that in 2006?
Your answer should be compact. 1.03. What is the ratio of the Value added (current US$) of Other small states in 2003 to that in 2007?
Your answer should be compact. 0.72. What is the ratio of the Value added (current US$) in Denmark in 2003 to that in 2007?
Your answer should be very brief. 0.94. What is the ratio of the Value added (current US$) of Nigeria in 2003 to that in 2007?
Provide a succinct answer. 0.52. What is the ratio of the Value added (current US$) of West Bank and Gaza in 2003 to that in 2007?
Provide a succinct answer. 0.78. What is the ratio of the Value added (current US$) of Other small states in 2004 to that in 2005?
Provide a short and direct response. 0.93. What is the ratio of the Value added (current US$) in Denmark in 2004 to that in 2005?
Your answer should be compact. 1.35. What is the ratio of the Value added (current US$) in Nigeria in 2004 to that in 2005?
Your answer should be very brief. 0.81. What is the ratio of the Value added (current US$) of West Bank and Gaza in 2004 to that in 2005?
Your answer should be compact. 1.18. What is the ratio of the Value added (current US$) in Other small states in 2004 to that in 2006?
Ensure brevity in your answer.  0.91. What is the ratio of the Value added (current US$) of Denmark in 2004 to that in 2006?
Keep it short and to the point. 1.24. What is the ratio of the Value added (current US$) in Nigeria in 2004 to that in 2006?
Provide a succinct answer. 0.64. What is the ratio of the Value added (current US$) in West Bank and Gaza in 2004 to that in 2006?
Make the answer very short. 1.12. What is the ratio of the Value added (current US$) of Other small states in 2004 to that in 2007?
Ensure brevity in your answer.  0.82. What is the ratio of the Value added (current US$) in Denmark in 2004 to that in 2007?
Your answer should be very brief. 1.09. What is the ratio of the Value added (current US$) in Nigeria in 2004 to that in 2007?
Provide a succinct answer. 0.55. What is the ratio of the Value added (current US$) of West Bank and Gaza in 2004 to that in 2007?
Make the answer very short. 0.85. What is the ratio of the Value added (current US$) of Other small states in 2005 to that in 2006?
Ensure brevity in your answer.  0.98. What is the ratio of the Value added (current US$) in Denmark in 2005 to that in 2006?
Keep it short and to the point. 0.92. What is the ratio of the Value added (current US$) in Nigeria in 2005 to that in 2006?
Your response must be concise. 0.79. What is the ratio of the Value added (current US$) of West Bank and Gaza in 2005 to that in 2006?
Make the answer very short. 0.95. What is the ratio of the Value added (current US$) in Other small states in 2005 to that in 2007?
Offer a terse response. 0.88. What is the ratio of the Value added (current US$) in Denmark in 2005 to that in 2007?
Offer a terse response. 0.81. What is the ratio of the Value added (current US$) in Nigeria in 2005 to that in 2007?
Your answer should be very brief. 0.68. What is the ratio of the Value added (current US$) of West Bank and Gaza in 2005 to that in 2007?
Offer a very short reply. 0.72. What is the ratio of the Value added (current US$) in Other small states in 2006 to that in 2007?
Make the answer very short. 0.9. What is the ratio of the Value added (current US$) of Denmark in 2006 to that in 2007?
Your answer should be very brief. 0.88. What is the ratio of the Value added (current US$) in Nigeria in 2006 to that in 2007?
Ensure brevity in your answer.  0.86. What is the ratio of the Value added (current US$) in West Bank and Gaza in 2006 to that in 2007?
Keep it short and to the point. 0.76. What is the difference between the highest and the second highest Value added (current US$) in Other small states?
Offer a very short reply. 4.00e+08. What is the difference between the highest and the second highest Value added (current US$) of Denmark?
Keep it short and to the point. 2.23e+08. What is the difference between the highest and the second highest Value added (current US$) in Nigeria?
Keep it short and to the point. 7.54e+09. What is the difference between the highest and the second highest Value added (current US$) of West Bank and Gaza?
Offer a very short reply. 1.41e+07. What is the difference between the highest and the lowest Value added (current US$) in Other small states?
Provide a short and direct response. 1.72e+09. What is the difference between the highest and the lowest Value added (current US$) in Denmark?
Offer a terse response. 1.05e+09. What is the difference between the highest and the lowest Value added (current US$) in Nigeria?
Make the answer very short. 3.94e+1. What is the difference between the highest and the lowest Value added (current US$) of West Bank and Gaza?
Provide a succinct answer. 1.00e+08. 